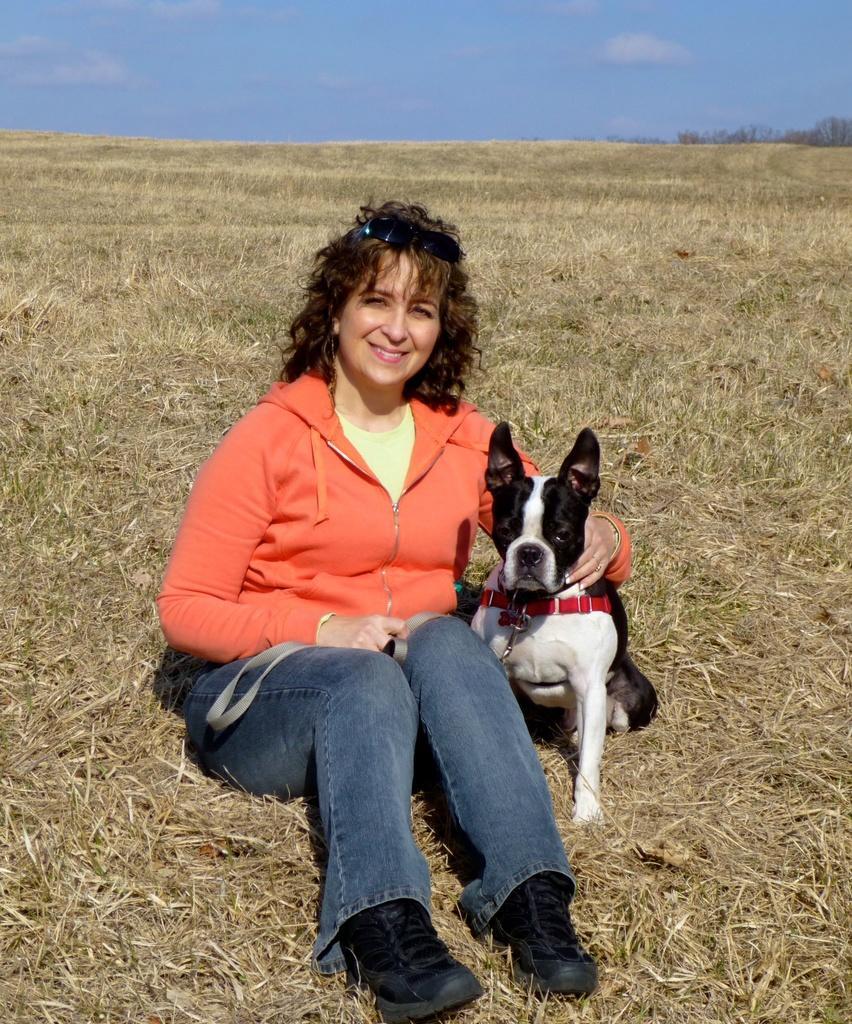In one or two sentences, can you explain what this image depicts? A woman is sitting in the grass, beside her it's a dog which is in the black and white color. This woman wore an orange color sweater, she is smiling. 